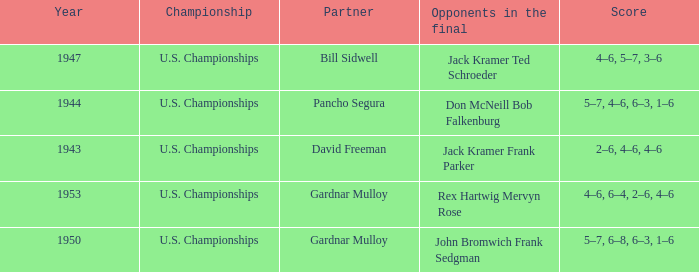Which Year has a Score of 5–7, 4–6, 6–3, 1–6? 1944.0. 